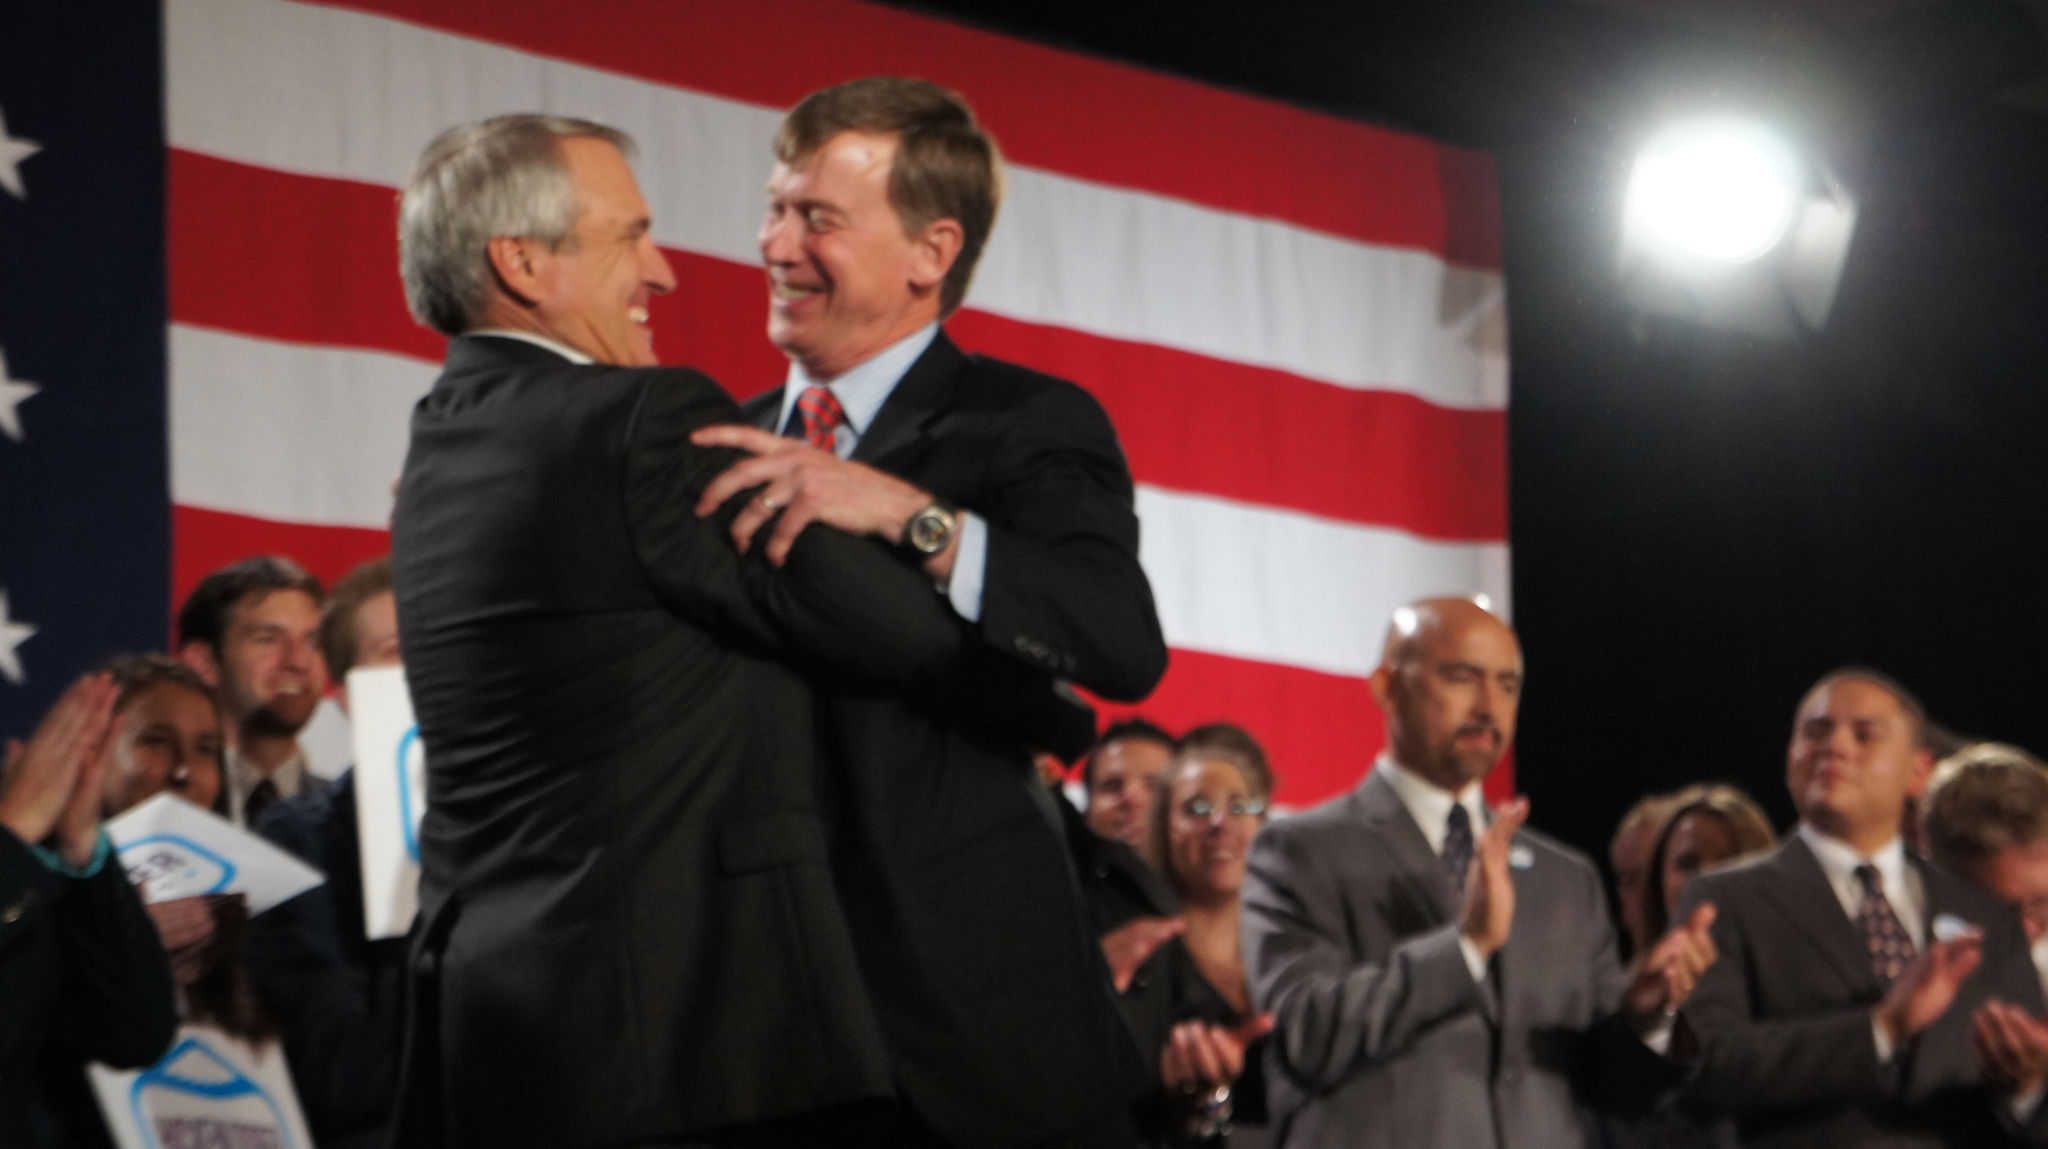Please provide a concise description of this image. In this image we can see two people hugging each other and smiling. In the background there are people. Some of them are holding boards. On the right we can see a light. There is a flag. 